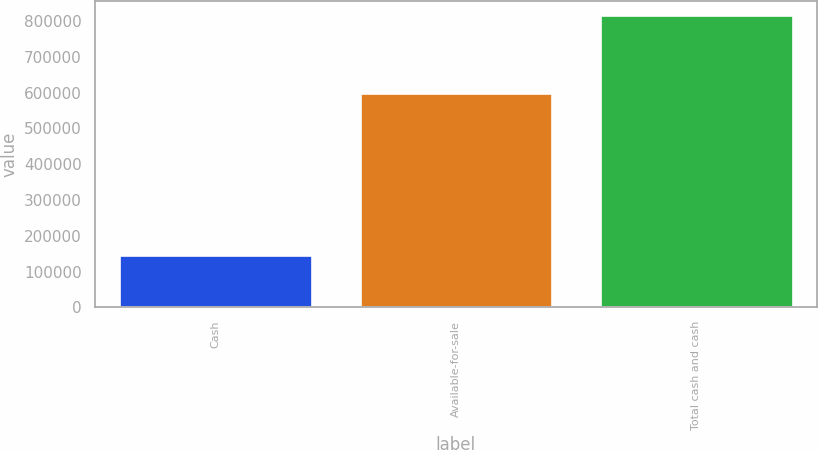<chart> <loc_0><loc_0><loc_500><loc_500><bar_chart><fcel>Cash<fcel>Available-for-sale<fcel>Total cash and cash<nl><fcel>147629<fcel>598962<fcel>816591<nl></chart> 